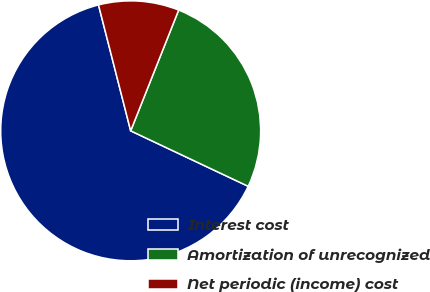Convert chart. <chart><loc_0><loc_0><loc_500><loc_500><pie_chart><fcel>Interest cost<fcel>Amortization of unrecognized<fcel>Net periodic (income) cost<nl><fcel>64.0%<fcel>26.0%<fcel>10.0%<nl></chart> 